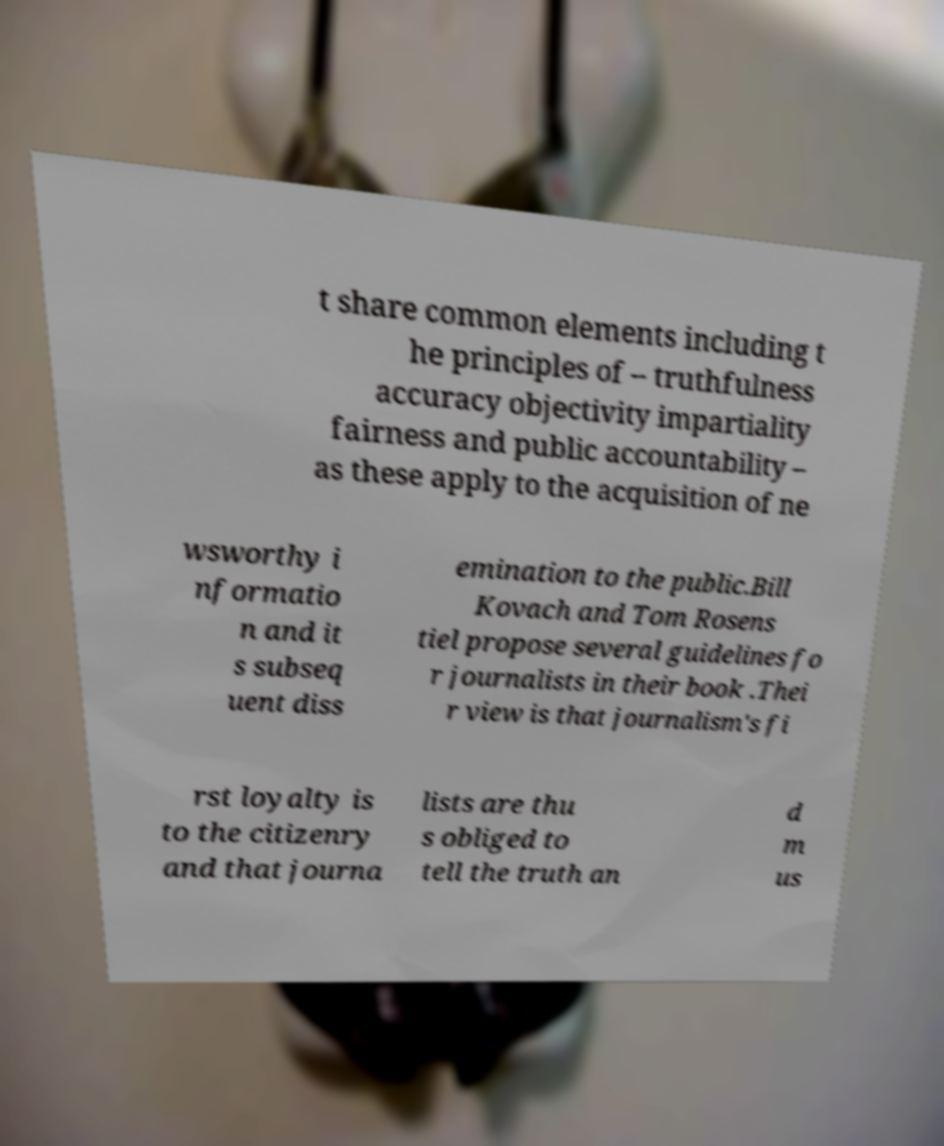There's text embedded in this image that I need extracted. Can you transcribe it verbatim? t share common elements including t he principles of – truthfulness accuracy objectivity impartiality fairness and public accountability – as these apply to the acquisition of ne wsworthy i nformatio n and it s subseq uent diss emination to the public.Bill Kovach and Tom Rosens tiel propose several guidelines fo r journalists in their book .Thei r view is that journalism's fi rst loyalty is to the citizenry and that journa lists are thu s obliged to tell the truth an d m us 